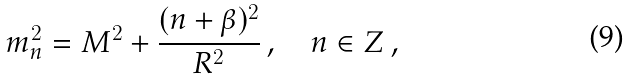<formula> <loc_0><loc_0><loc_500><loc_500>m _ { n } ^ { 2 } = M ^ { 2 } + \frac { ( n + \beta ) ^ { 2 } } { R ^ { 2 } } \, , \quad n \in Z \, ,</formula> 